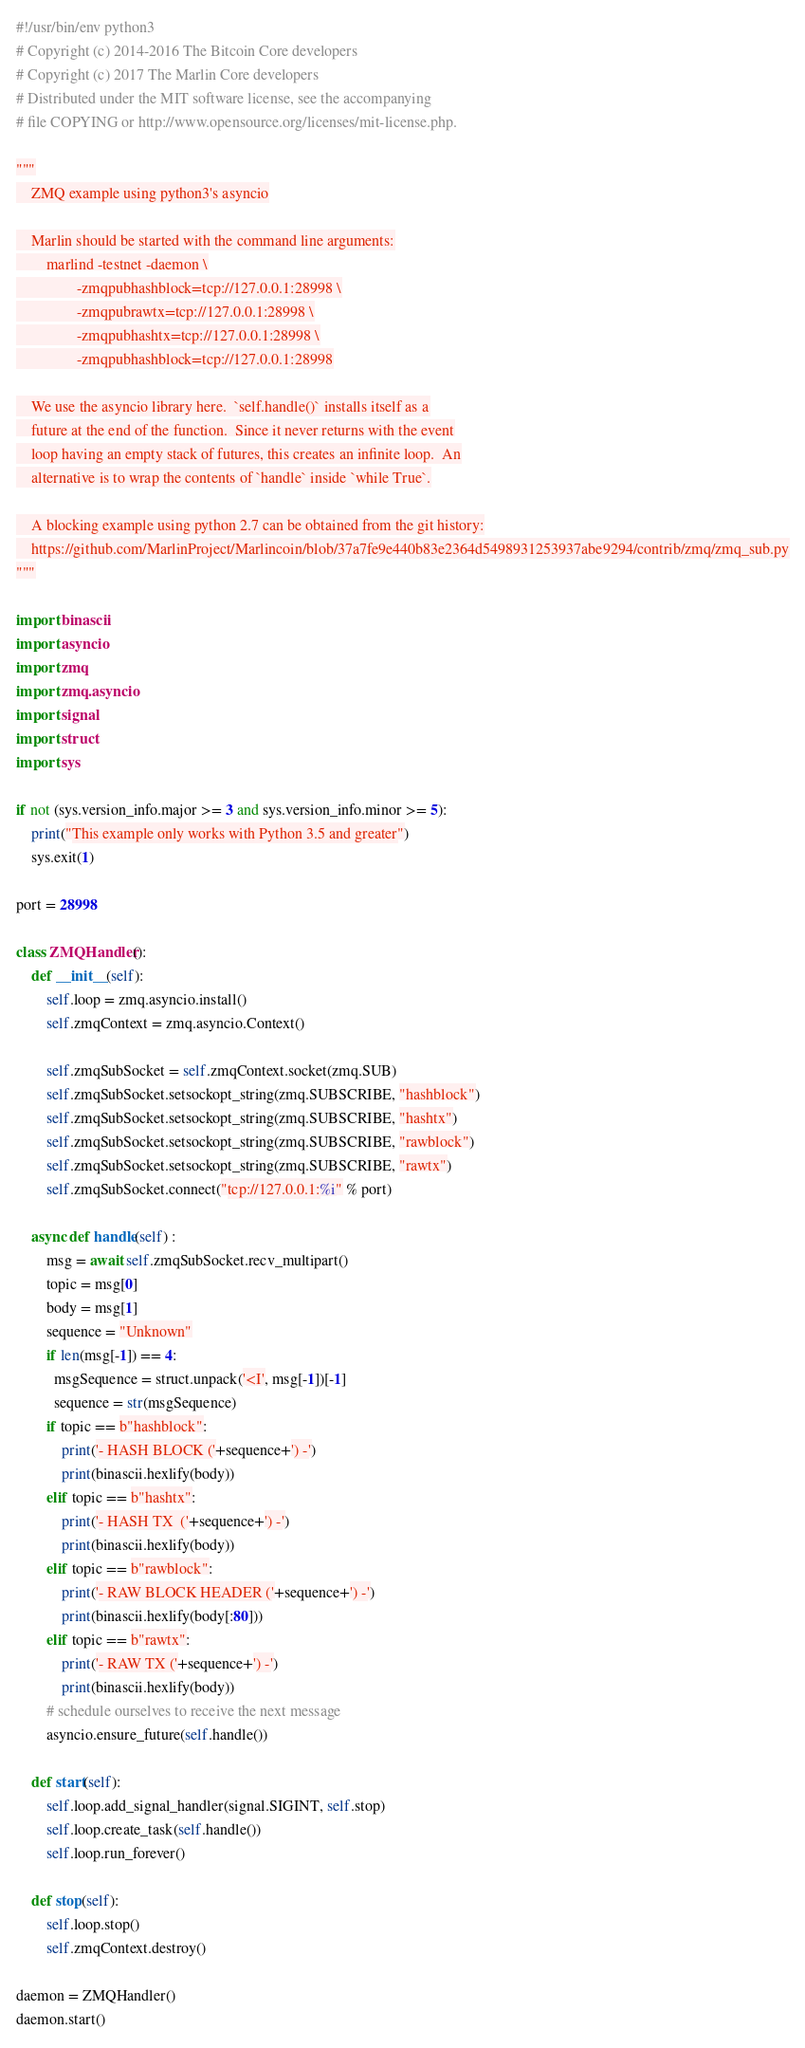<code> <loc_0><loc_0><loc_500><loc_500><_Python_>#!/usr/bin/env python3
# Copyright (c) 2014-2016 The Bitcoin Core developers
# Copyright (c) 2017 The Marlin Core developers
# Distributed under the MIT software license, see the accompanying
# file COPYING or http://www.opensource.org/licenses/mit-license.php.

"""
    ZMQ example using python3's asyncio

    Marlin should be started with the command line arguments:
        marlind -testnet -daemon \
                -zmqpubhashblock=tcp://127.0.0.1:28998 \
                -zmqpubrawtx=tcp://127.0.0.1:28998 \
                -zmqpubhashtx=tcp://127.0.0.1:28998 \
                -zmqpubhashblock=tcp://127.0.0.1:28998

    We use the asyncio library here.  `self.handle()` installs itself as a
    future at the end of the function.  Since it never returns with the event
    loop having an empty stack of futures, this creates an infinite loop.  An
    alternative is to wrap the contents of `handle` inside `while True`.

    A blocking example using python 2.7 can be obtained from the git history:
    https://github.com/MarlinProject/Marlincoin/blob/37a7fe9e440b83e2364d5498931253937abe9294/contrib/zmq/zmq_sub.py
"""

import binascii
import asyncio
import zmq
import zmq.asyncio
import signal
import struct
import sys

if not (sys.version_info.major >= 3 and sys.version_info.minor >= 5):
    print("This example only works with Python 3.5 and greater")
    sys.exit(1)

port = 28998

class ZMQHandler():
    def __init__(self):
        self.loop = zmq.asyncio.install()
        self.zmqContext = zmq.asyncio.Context()

        self.zmqSubSocket = self.zmqContext.socket(zmq.SUB)
        self.zmqSubSocket.setsockopt_string(zmq.SUBSCRIBE, "hashblock")
        self.zmqSubSocket.setsockopt_string(zmq.SUBSCRIBE, "hashtx")
        self.zmqSubSocket.setsockopt_string(zmq.SUBSCRIBE, "rawblock")
        self.zmqSubSocket.setsockopt_string(zmq.SUBSCRIBE, "rawtx")
        self.zmqSubSocket.connect("tcp://127.0.0.1:%i" % port)

    async def handle(self) :
        msg = await self.zmqSubSocket.recv_multipart()
        topic = msg[0]
        body = msg[1]
        sequence = "Unknown"
        if len(msg[-1]) == 4:
          msgSequence = struct.unpack('<I', msg[-1])[-1]
          sequence = str(msgSequence)
        if topic == b"hashblock":
            print('- HASH BLOCK ('+sequence+') -')
            print(binascii.hexlify(body))
        elif topic == b"hashtx":
            print('- HASH TX  ('+sequence+') -')
            print(binascii.hexlify(body))
        elif topic == b"rawblock":
            print('- RAW BLOCK HEADER ('+sequence+') -')
            print(binascii.hexlify(body[:80]))
        elif topic == b"rawtx":
            print('- RAW TX ('+sequence+') -')
            print(binascii.hexlify(body))
        # schedule ourselves to receive the next message
        asyncio.ensure_future(self.handle())

    def start(self):
        self.loop.add_signal_handler(signal.SIGINT, self.stop)
        self.loop.create_task(self.handle())
        self.loop.run_forever()

    def stop(self):
        self.loop.stop()
        self.zmqContext.destroy()

daemon = ZMQHandler()
daemon.start()
</code> 